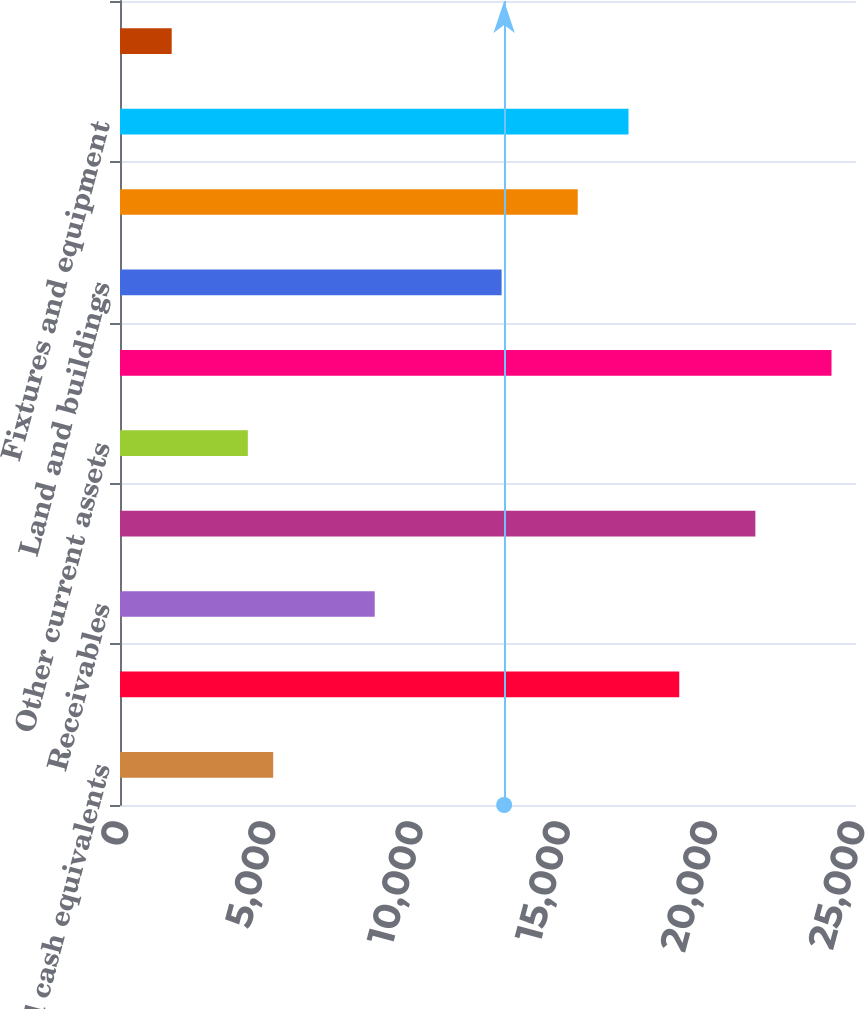<chart> <loc_0><loc_0><loc_500><loc_500><bar_chart><fcel>Cash and cash equivalents<fcel>Short-term investments<fcel>Receivables<fcel>Merchandise inventories<fcel>Other current assets<fcel>Total current assets<fcel>Land and buildings<fcel>Leasehold improvements<fcel>Fixtures and equipment<fcel>Property under master and<nl><fcel>5204<fcel>18996<fcel>8652<fcel>21582<fcel>4342<fcel>24168<fcel>12962<fcel>15548<fcel>17272<fcel>1756<nl></chart> 